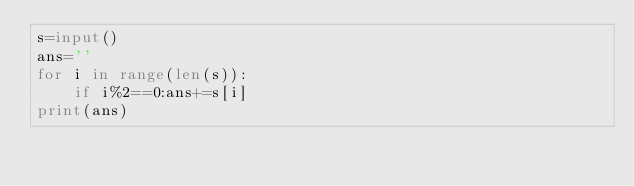Convert code to text. <code><loc_0><loc_0><loc_500><loc_500><_Python_>s=input()
ans=''
for i in range(len(s)):
    if i%2==0:ans+=s[i]
print(ans)
</code> 